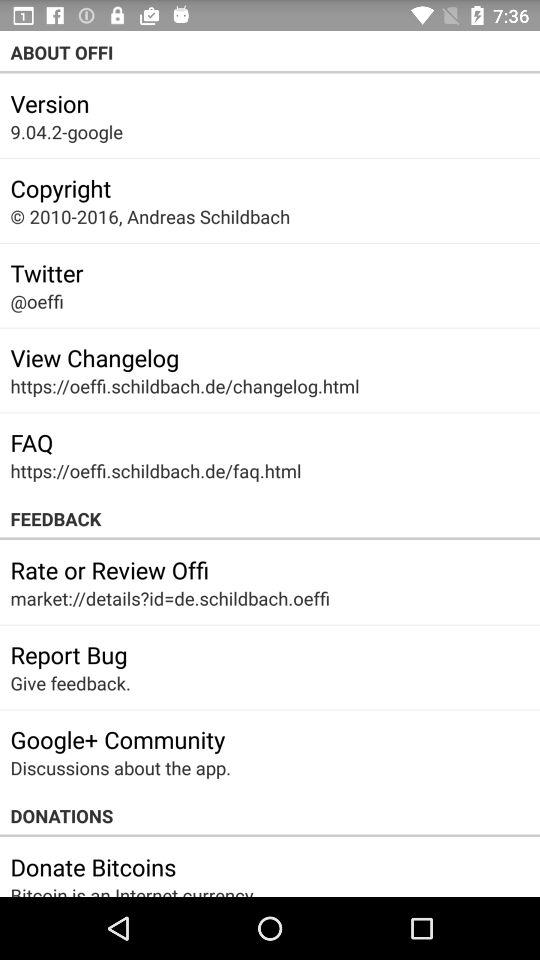What's the hyperlink for the FAQ? The hyperlink for the FAQ is https://oeffi.schildbach.de/faq.html. 